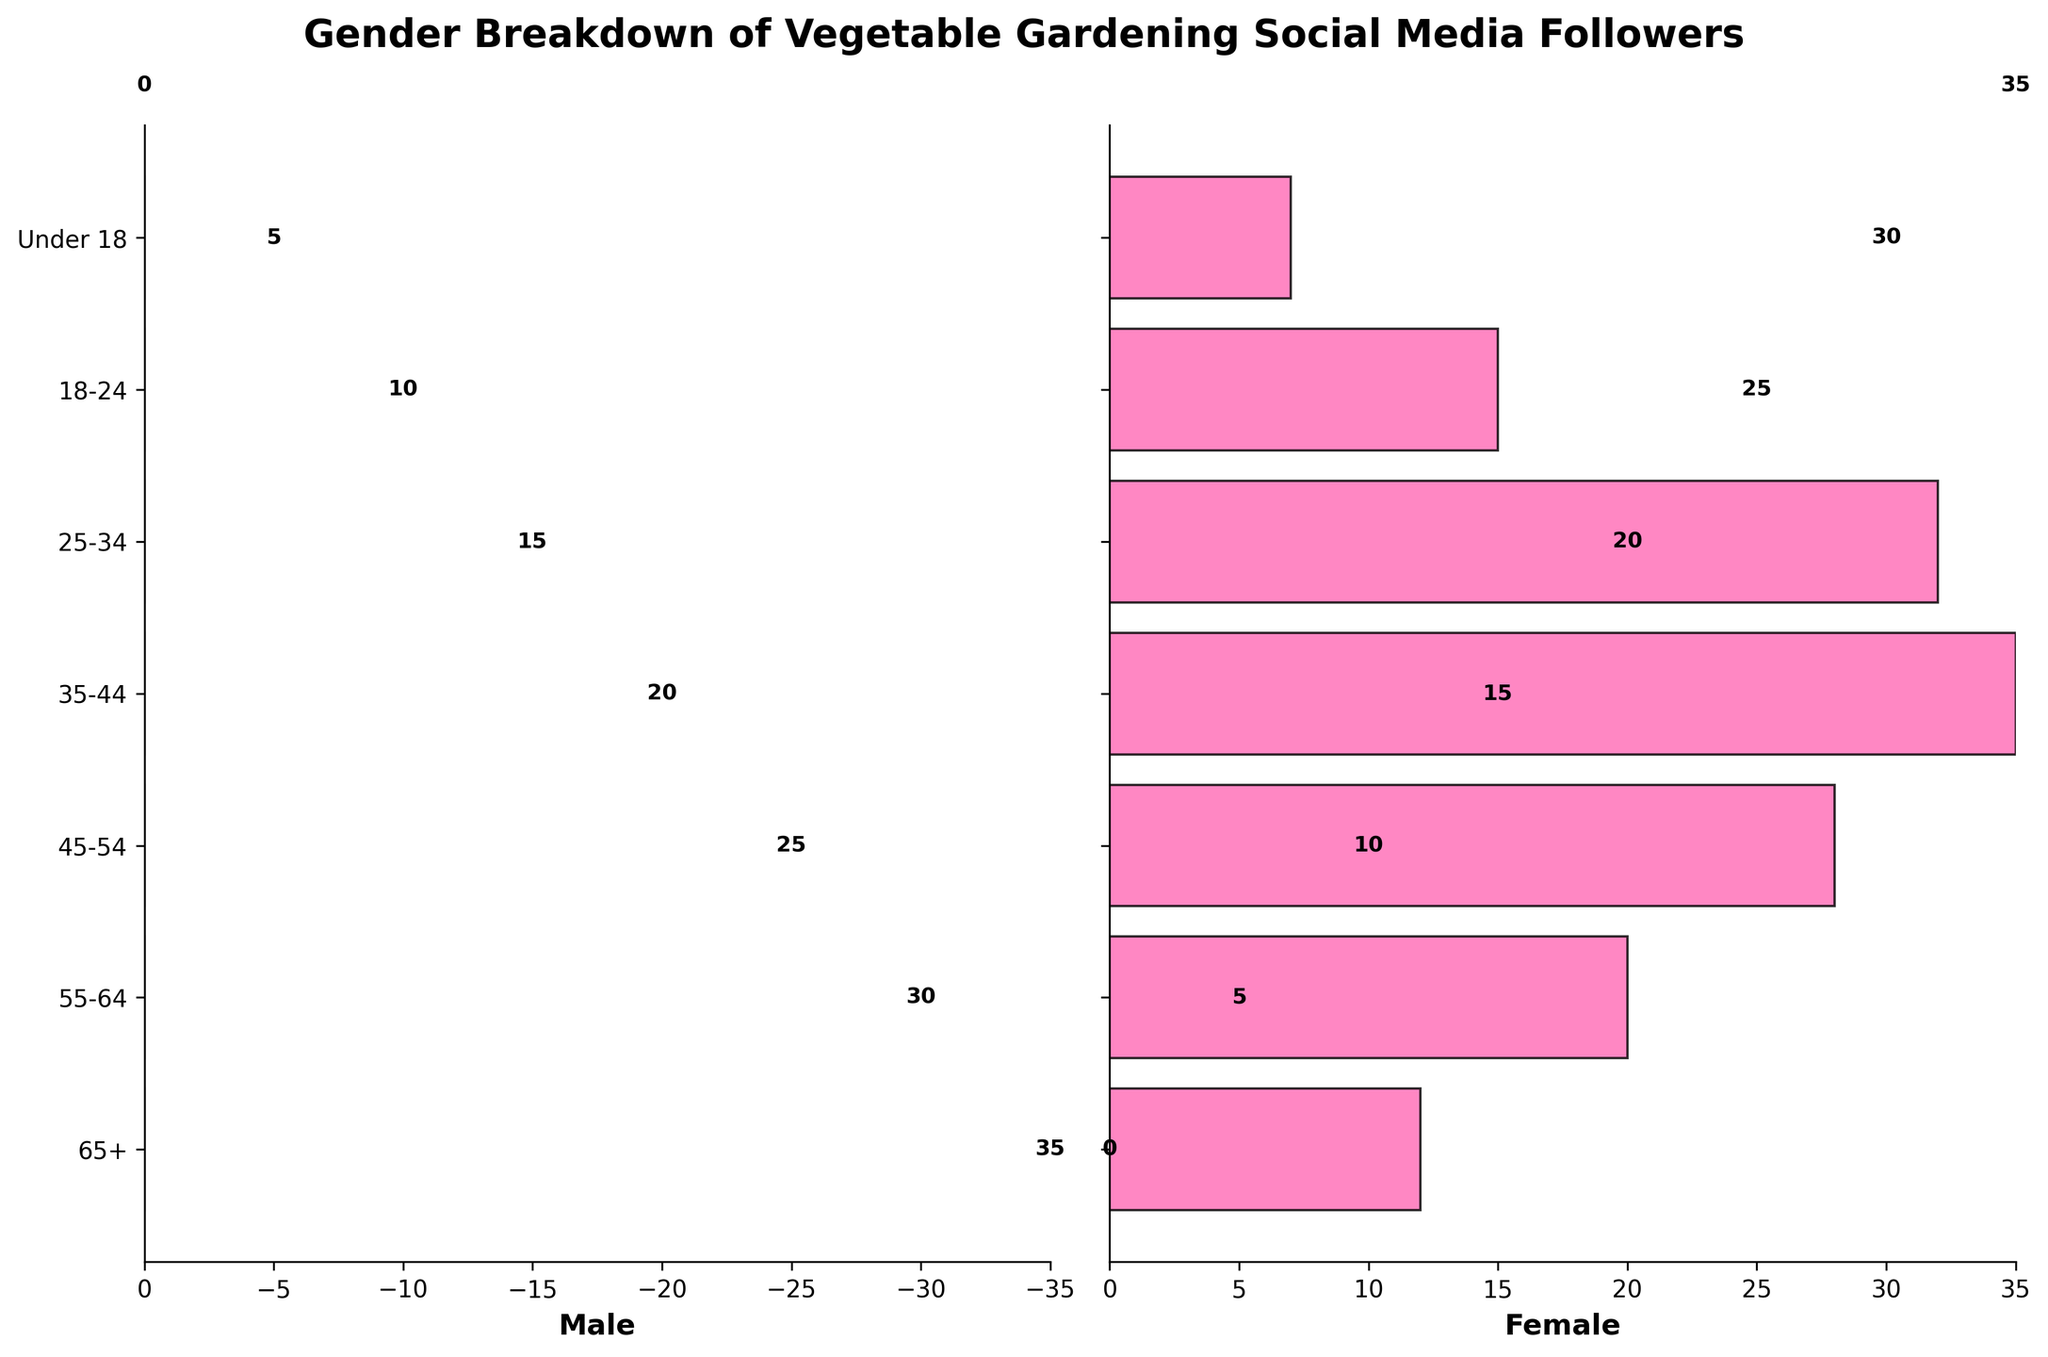What is the total number of male followers in the 25-34 age group? According to the plot, the number of male followers in the 25-34 age group is -25. Since we only care about the magnitude, we use the absolute value.
Answer: 25 Which age group has the highest number of female followers? From the plot, the age group 35-44 has the highest positive bar length for females, indicating it has the most female followers.
Answer: 35-44 What is the difference in the number of followers between males and females in the 45-54 age group? For the 45-54 age group, the numbers are 22 males and 28 females implying a difference of 28 - 22.
Answer: 6 Which age group has the smallest number of male followers? The age group with the smallest male followers is Under 18 as its negative bar has the smallest magnitude.
Answer: Under 18 Compare the number of female followers in the 65+ age group to the number of male followers in the same age group. The number of female followers in the 65+ age group is 12, while the number of male followers is 8. Comparing these values, females have more followers.
Answer: Females have more What is the total number of followers (both genders combined) in the 18-24 age group? The number of male followers is 10, and female followers is 15. The total followers is 10 + 15.
Answer: 25 How does the number of male followers in the 35-44 age group compare to female followers in the same group? The 35-44 age group has 30 male followers and 35 female followers. Thus, comparing these values, there are more females.
Answer: More females What is the most balanced age group in terms of gender ratio? The 18-24 age group has 10 male followers and 15 female followers, making it the most balanced (difference is 5). The other groups have larger differences.
Answer: 18-24 Is the number of female followers in the 25-34 age group higher than in the 55-64 age group? The number of female followers in the 25-34 age group is 32, whereas it is 20 in the 55-64 group. Thus, it is higher for the 25-34 group.
Answer: Yes What is the percentage of female followers in the 35-44 age group compared to total followers in that group? The total number of followers in the 35-44 age group is 30 (male) + 35 (female) = 65. The percentage for female followers is (35 / 65) * 100%.
Answer: 53.8% 